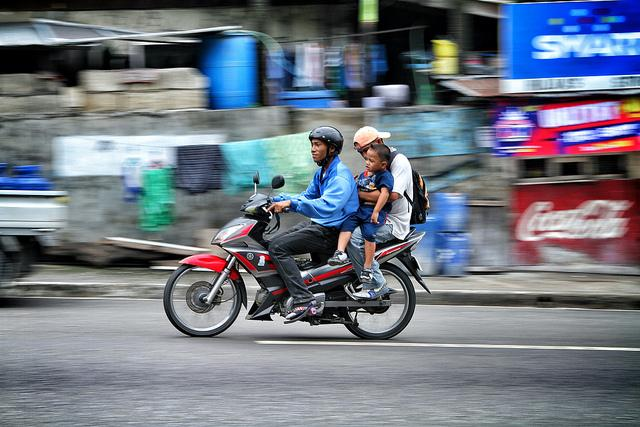What year was Coca-Cola founded?

Choices:
A) 1843
B) 1892
C) 1881
D) 1890 1892 